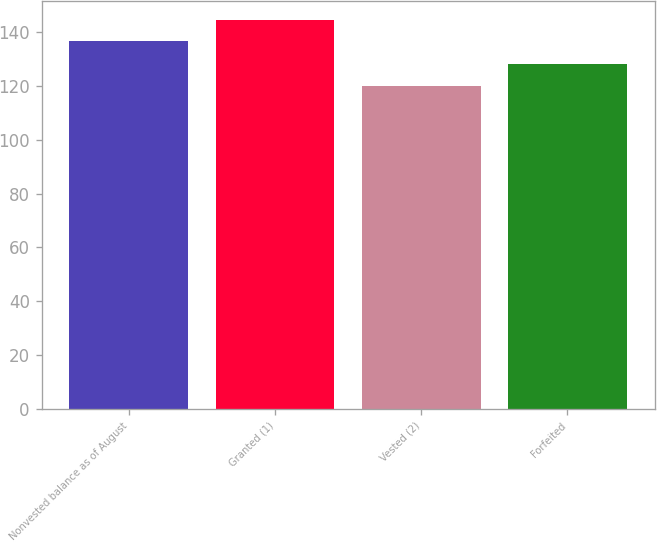Convert chart to OTSL. <chart><loc_0><loc_0><loc_500><loc_500><bar_chart><fcel>Nonvested balance as of August<fcel>Granted (1)<fcel>Vested (2)<fcel>Forfeited<nl><fcel>136.66<fcel>144.52<fcel>119.89<fcel>128.05<nl></chart> 